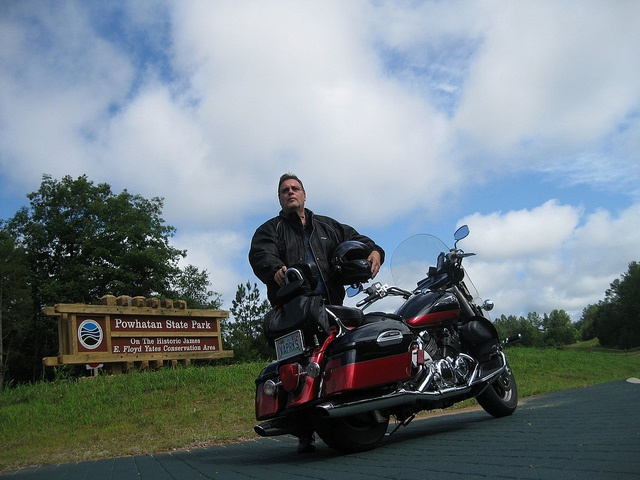Describe the objects in this image and their specific colors. I can see motorcycle in gray, black, maroon, and lightgray tones and people in gray, black, and lightblue tones in this image. 